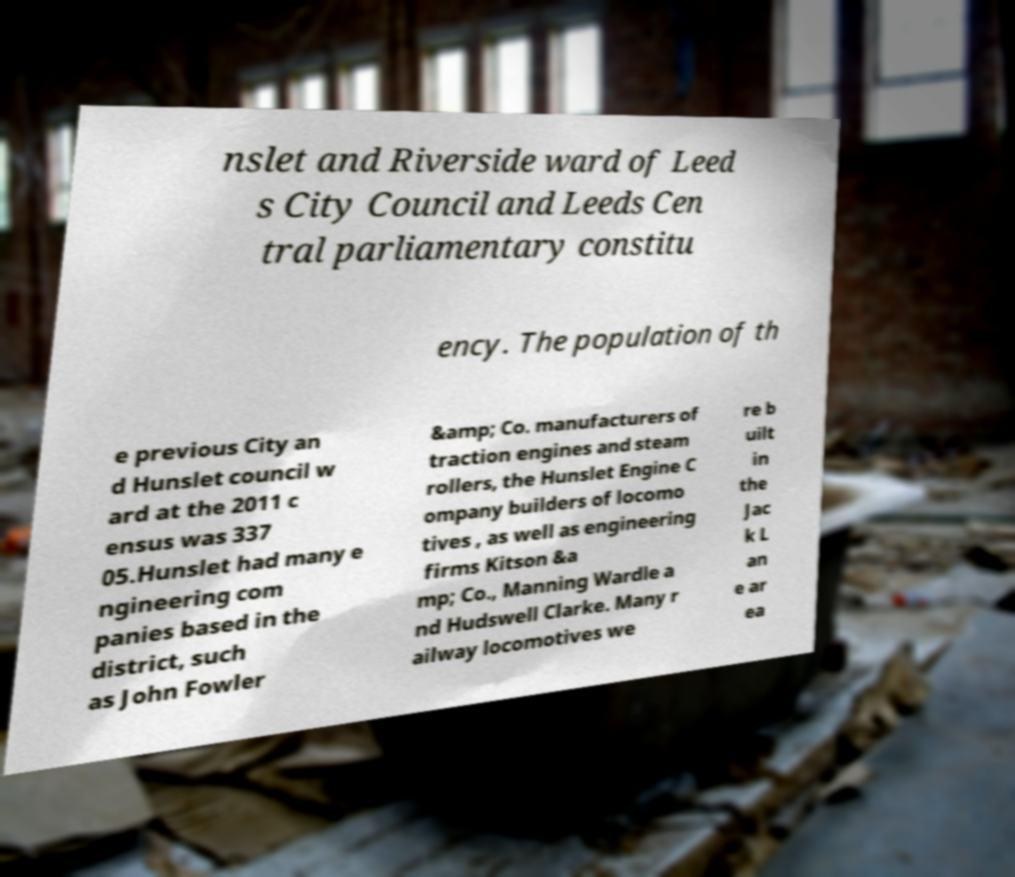I need the written content from this picture converted into text. Can you do that? nslet and Riverside ward of Leed s City Council and Leeds Cen tral parliamentary constitu ency. The population of th e previous City an d Hunslet council w ard at the 2011 c ensus was 337 05.Hunslet had many e ngineering com panies based in the district, such as John Fowler &amp; Co. manufacturers of traction engines and steam rollers, the Hunslet Engine C ompany builders of locomo tives , as well as engineering firms Kitson &a mp; Co., Manning Wardle a nd Hudswell Clarke. Many r ailway locomotives we re b uilt in the Jac k L an e ar ea 